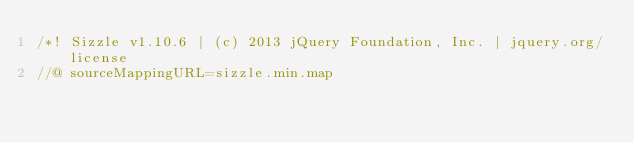<code> <loc_0><loc_0><loc_500><loc_500><_JavaScript_>/*! Sizzle v1.10.6 | (c) 2013 jQuery Foundation, Inc. | jquery.org/license
//@ sourceMappingURL=sizzle.min.map</code> 